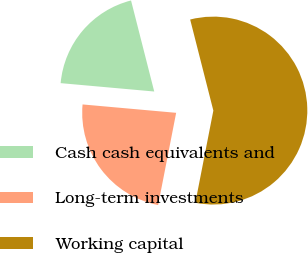Convert chart. <chart><loc_0><loc_0><loc_500><loc_500><pie_chart><fcel>Cash cash equivalents and<fcel>Long-term investments<fcel>Working capital<nl><fcel>19.61%<fcel>23.35%<fcel>57.04%<nl></chart> 